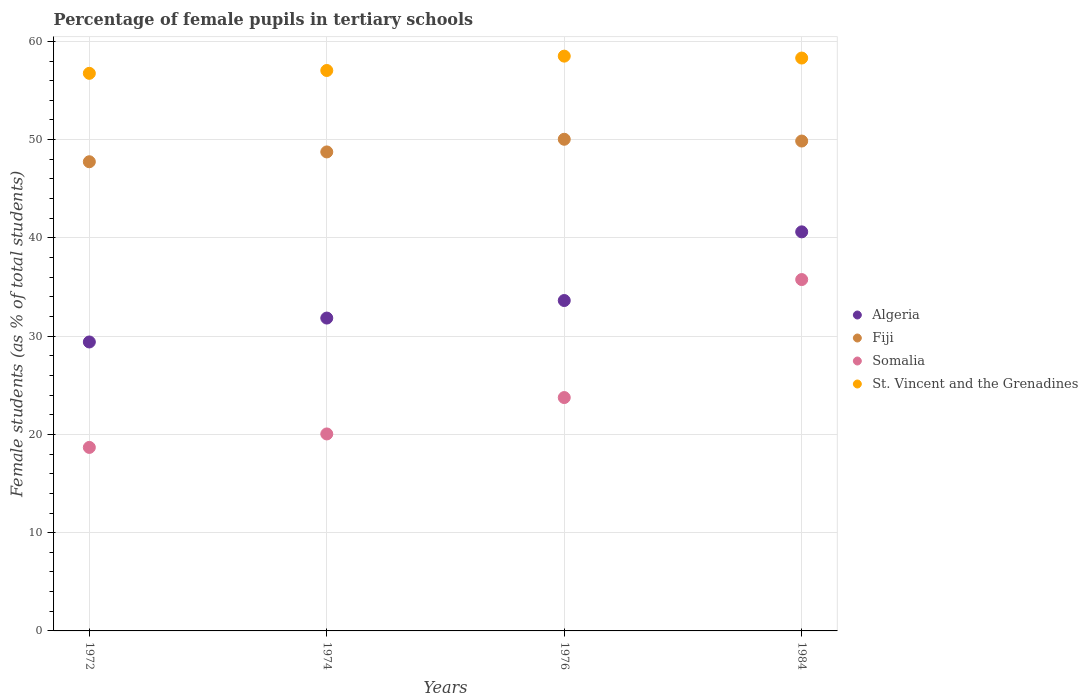How many different coloured dotlines are there?
Your answer should be very brief. 4. What is the percentage of female pupils in tertiary schools in Somalia in 1974?
Your answer should be compact. 20.05. Across all years, what is the maximum percentage of female pupils in tertiary schools in Algeria?
Give a very brief answer. 40.61. Across all years, what is the minimum percentage of female pupils in tertiary schools in Somalia?
Offer a terse response. 18.68. In which year was the percentage of female pupils in tertiary schools in Fiji maximum?
Provide a succinct answer. 1976. In which year was the percentage of female pupils in tertiary schools in St. Vincent and the Grenadines minimum?
Offer a terse response. 1972. What is the total percentage of female pupils in tertiary schools in Fiji in the graph?
Keep it short and to the point. 196.39. What is the difference between the percentage of female pupils in tertiary schools in St. Vincent and the Grenadines in 1974 and that in 1976?
Your answer should be very brief. -1.46. What is the difference between the percentage of female pupils in tertiary schools in Somalia in 1984 and the percentage of female pupils in tertiary schools in Fiji in 1976?
Make the answer very short. -14.28. What is the average percentage of female pupils in tertiary schools in Fiji per year?
Keep it short and to the point. 49.1. In the year 1974, what is the difference between the percentage of female pupils in tertiary schools in Fiji and percentage of female pupils in tertiary schools in St. Vincent and the Grenadines?
Ensure brevity in your answer.  -8.29. In how many years, is the percentage of female pupils in tertiary schools in St. Vincent and the Grenadines greater than 24 %?
Your response must be concise. 4. What is the ratio of the percentage of female pupils in tertiary schools in St. Vincent and the Grenadines in 1972 to that in 1976?
Provide a short and direct response. 0.97. What is the difference between the highest and the second highest percentage of female pupils in tertiary schools in Fiji?
Provide a succinct answer. 0.18. What is the difference between the highest and the lowest percentage of female pupils in tertiary schools in Fiji?
Your answer should be compact. 2.29. Is it the case that in every year, the sum of the percentage of female pupils in tertiary schools in Algeria and percentage of female pupils in tertiary schools in Somalia  is greater than the sum of percentage of female pupils in tertiary schools in St. Vincent and the Grenadines and percentage of female pupils in tertiary schools in Fiji?
Your answer should be compact. No. Is it the case that in every year, the sum of the percentage of female pupils in tertiary schools in Algeria and percentage of female pupils in tertiary schools in Fiji  is greater than the percentage of female pupils in tertiary schools in Somalia?
Your answer should be very brief. Yes. Is the percentage of female pupils in tertiary schools in Fiji strictly greater than the percentage of female pupils in tertiary schools in Somalia over the years?
Provide a succinct answer. Yes. Is the percentage of female pupils in tertiary schools in Algeria strictly less than the percentage of female pupils in tertiary schools in St. Vincent and the Grenadines over the years?
Your response must be concise. Yes. How many years are there in the graph?
Your response must be concise. 4. Are the values on the major ticks of Y-axis written in scientific E-notation?
Give a very brief answer. No. Does the graph contain grids?
Ensure brevity in your answer.  Yes. What is the title of the graph?
Provide a short and direct response. Percentage of female pupils in tertiary schools. Does "Slovenia" appear as one of the legend labels in the graph?
Ensure brevity in your answer.  No. What is the label or title of the Y-axis?
Offer a very short reply. Female students (as % of total students). What is the Female students (as % of total students) in Algeria in 1972?
Your response must be concise. 29.41. What is the Female students (as % of total students) in Fiji in 1972?
Offer a terse response. 47.75. What is the Female students (as % of total students) in Somalia in 1972?
Provide a succinct answer. 18.68. What is the Female students (as % of total students) of St. Vincent and the Grenadines in 1972?
Provide a short and direct response. 56.75. What is the Female students (as % of total students) of Algeria in 1974?
Keep it short and to the point. 31.84. What is the Female students (as % of total students) in Fiji in 1974?
Keep it short and to the point. 48.75. What is the Female students (as % of total students) of Somalia in 1974?
Provide a short and direct response. 20.05. What is the Female students (as % of total students) of St. Vincent and the Grenadines in 1974?
Give a very brief answer. 57.04. What is the Female students (as % of total students) of Algeria in 1976?
Your response must be concise. 33.63. What is the Female students (as % of total students) of Fiji in 1976?
Ensure brevity in your answer.  50.04. What is the Female students (as % of total students) in Somalia in 1976?
Offer a very short reply. 23.75. What is the Female students (as % of total students) of St. Vincent and the Grenadines in 1976?
Provide a succinct answer. 58.5. What is the Female students (as % of total students) in Algeria in 1984?
Offer a terse response. 40.61. What is the Female students (as % of total students) in Fiji in 1984?
Your answer should be compact. 49.86. What is the Female students (as % of total students) of Somalia in 1984?
Offer a very short reply. 35.76. What is the Female students (as % of total students) of St. Vincent and the Grenadines in 1984?
Your answer should be compact. 58.3. Across all years, what is the maximum Female students (as % of total students) of Algeria?
Provide a short and direct response. 40.61. Across all years, what is the maximum Female students (as % of total students) of Fiji?
Provide a succinct answer. 50.04. Across all years, what is the maximum Female students (as % of total students) in Somalia?
Your response must be concise. 35.76. Across all years, what is the maximum Female students (as % of total students) in St. Vincent and the Grenadines?
Your answer should be compact. 58.5. Across all years, what is the minimum Female students (as % of total students) of Algeria?
Keep it short and to the point. 29.41. Across all years, what is the minimum Female students (as % of total students) of Fiji?
Keep it short and to the point. 47.75. Across all years, what is the minimum Female students (as % of total students) in Somalia?
Provide a succinct answer. 18.68. Across all years, what is the minimum Female students (as % of total students) of St. Vincent and the Grenadines?
Provide a succinct answer. 56.75. What is the total Female students (as % of total students) of Algeria in the graph?
Provide a succinct answer. 135.49. What is the total Female students (as % of total students) in Fiji in the graph?
Give a very brief answer. 196.39. What is the total Female students (as % of total students) in Somalia in the graph?
Your answer should be very brief. 98.23. What is the total Female students (as % of total students) of St. Vincent and the Grenadines in the graph?
Give a very brief answer. 230.58. What is the difference between the Female students (as % of total students) of Algeria in 1972 and that in 1974?
Ensure brevity in your answer.  -2.43. What is the difference between the Female students (as % of total students) in Fiji in 1972 and that in 1974?
Your answer should be compact. -1. What is the difference between the Female students (as % of total students) of Somalia in 1972 and that in 1974?
Give a very brief answer. -1.37. What is the difference between the Female students (as % of total students) of St. Vincent and the Grenadines in 1972 and that in 1974?
Your answer should be compact. -0.29. What is the difference between the Female students (as % of total students) in Algeria in 1972 and that in 1976?
Provide a short and direct response. -4.22. What is the difference between the Female students (as % of total students) in Fiji in 1972 and that in 1976?
Ensure brevity in your answer.  -2.29. What is the difference between the Female students (as % of total students) of Somalia in 1972 and that in 1976?
Ensure brevity in your answer.  -5.07. What is the difference between the Female students (as % of total students) in St. Vincent and the Grenadines in 1972 and that in 1976?
Offer a terse response. -1.75. What is the difference between the Female students (as % of total students) of Algeria in 1972 and that in 1984?
Make the answer very short. -11.21. What is the difference between the Female students (as % of total students) of Fiji in 1972 and that in 1984?
Your response must be concise. -2.11. What is the difference between the Female students (as % of total students) of Somalia in 1972 and that in 1984?
Your answer should be compact. -17.08. What is the difference between the Female students (as % of total students) in St. Vincent and the Grenadines in 1972 and that in 1984?
Provide a short and direct response. -1.56. What is the difference between the Female students (as % of total students) in Algeria in 1974 and that in 1976?
Make the answer very short. -1.79. What is the difference between the Female students (as % of total students) of Fiji in 1974 and that in 1976?
Give a very brief answer. -1.29. What is the difference between the Female students (as % of total students) in Somalia in 1974 and that in 1976?
Offer a terse response. -3.7. What is the difference between the Female students (as % of total students) in St. Vincent and the Grenadines in 1974 and that in 1976?
Offer a terse response. -1.46. What is the difference between the Female students (as % of total students) in Algeria in 1974 and that in 1984?
Provide a short and direct response. -8.77. What is the difference between the Female students (as % of total students) of Fiji in 1974 and that in 1984?
Offer a terse response. -1.11. What is the difference between the Female students (as % of total students) in Somalia in 1974 and that in 1984?
Provide a succinct answer. -15.71. What is the difference between the Female students (as % of total students) of St. Vincent and the Grenadines in 1974 and that in 1984?
Offer a terse response. -1.27. What is the difference between the Female students (as % of total students) in Algeria in 1976 and that in 1984?
Your answer should be compact. -6.99. What is the difference between the Female students (as % of total students) in Fiji in 1976 and that in 1984?
Provide a short and direct response. 0.18. What is the difference between the Female students (as % of total students) of Somalia in 1976 and that in 1984?
Your response must be concise. -12.01. What is the difference between the Female students (as % of total students) in St. Vincent and the Grenadines in 1976 and that in 1984?
Make the answer very short. 0.19. What is the difference between the Female students (as % of total students) of Algeria in 1972 and the Female students (as % of total students) of Fiji in 1974?
Provide a short and direct response. -19.34. What is the difference between the Female students (as % of total students) in Algeria in 1972 and the Female students (as % of total students) in Somalia in 1974?
Offer a terse response. 9.36. What is the difference between the Female students (as % of total students) in Algeria in 1972 and the Female students (as % of total students) in St. Vincent and the Grenadines in 1974?
Offer a terse response. -27.63. What is the difference between the Female students (as % of total students) of Fiji in 1972 and the Female students (as % of total students) of Somalia in 1974?
Keep it short and to the point. 27.7. What is the difference between the Female students (as % of total students) of Fiji in 1972 and the Female students (as % of total students) of St. Vincent and the Grenadines in 1974?
Your answer should be compact. -9.29. What is the difference between the Female students (as % of total students) of Somalia in 1972 and the Female students (as % of total students) of St. Vincent and the Grenadines in 1974?
Keep it short and to the point. -38.36. What is the difference between the Female students (as % of total students) of Algeria in 1972 and the Female students (as % of total students) of Fiji in 1976?
Keep it short and to the point. -20.63. What is the difference between the Female students (as % of total students) in Algeria in 1972 and the Female students (as % of total students) in Somalia in 1976?
Offer a very short reply. 5.66. What is the difference between the Female students (as % of total students) in Algeria in 1972 and the Female students (as % of total students) in St. Vincent and the Grenadines in 1976?
Your answer should be very brief. -29.09. What is the difference between the Female students (as % of total students) in Fiji in 1972 and the Female students (as % of total students) in Somalia in 1976?
Offer a terse response. 24. What is the difference between the Female students (as % of total students) of Fiji in 1972 and the Female students (as % of total students) of St. Vincent and the Grenadines in 1976?
Provide a short and direct response. -10.75. What is the difference between the Female students (as % of total students) of Somalia in 1972 and the Female students (as % of total students) of St. Vincent and the Grenadines in 1976?
Offer a terse response. -39.82. What is the difference between the Female students (as % of total students) in Algeria in 1972 and the Female students (as % of total students) in Fiji in 1984?
Give a very brief answer. -20.45. What is the difference between the Female students (as % of total students) of Algeria in 1972 and the Female students (as % of total students) of Somalia in 1984?
Provide a short and direct response. -6.35. What is the difference between the Female students (as % of total students) in Algeria in 1972 and the Female students (as % of total students) in St. Vincent and the Grenadines in 1984?
Provide a short and direct response. -28.9. What is the difference between the Female students (as % of total students) of Fiji in 1972 and the Female students (as % of total students) of Somalia in 1984?
Make the answer very short. 11.99. What is the difference between the Female students (as % of total students) of Fiji in 1972 and the Female students (as % of total students) of St. Vincent and the Grenadines in 1984?
Keep it short and to the point. -10.55. What is the difference between the Female students (as % of total students) of Somalia in 1972 and the Female students (as % of total students) of St. Vincent and the Grenadines in 1984?
Offer a terse response. -39.63. What is the difference between the Female students (as % of total students) of Algeria in 1974 and the Female students (as % of total students) of Fiji in 1976?
Provide a succinct answer. -18.2. What is the difference between the Female students (as % of total students) in Algeria in 1974 and the Female students (as % of total students) in Somalia in 1976?
Provide a short and direct response. 8.09. What is the difference between the Female students (as % of total students) of Algeria in 1974 and the Female students (as % of total students) of St. Vincent and the Grenadines in 1976?
Give a very brief answer. -26.66. What is the difference between the Female students (as % of total students) in Fiji in 1974 and the Female students (as % of total students) in Somalia in 1976?
Your answer should be compact. 25. What is the difference between the Female students (as % of total students) in Fiji in 1974 and the Female students (as % of total students) in St. Vincent and the Grenadines in 1976?
Your answer should be compact. -9.75. What is the difference between the Female students (as % of total students) of Somalia in 1974 and the Female students (as % of total students) of St. Vincent and the Grenadines in 1976?
Provide a succinct answer. -38.45. What is the difference between the Female students (as % of total students) in Algeria in 1974 and the Female students (as % of total students) in Fiji in 1984?
Provide a short and direct response. -18.02. What is the difference between the Female students (as % of total students) of Algeria in 1974 and the Female students (as % of total students) of Somalia in 1984?
Give a very brief answer. -3.92. What is the difference between the Female students (as % of total students) of Algeria in 1974 and the Female students (as % of total students) of St. Vincent and the Grenadines in 1984?
Your answer should be compact. -26.46. What is the difference between the Female students (as % of total students) of Fiji in 1974 and the Female students (as % of total students) of Somalia in 1984?
Offer a terse response. 12.99. What is the difference between the Female students (as % of total students) in Fiji in 1974 and the Female students (as % of total students) in St. Vincent and the Grenadines in 1984?
Your response must be concise. -9.55. What is the difference between the Female students (as % of total students) of Somalia in 1974 and the Female students (as % of total students) of St. Vincent and the Grenadines in 1984?
Give a very brief answer. -38.26. What is the difference between the Female students (as % of total students) in Algeria in 1976 and the Female students (as % of total students) in Fiji in 1984?
Offer a very short reply. -16.23. What is the difference between the Female students (as % of total students) of Algeria in 1976 and the Female students (as % of total students) of Somalia in 1984?
Offer a very short reply. -2.13. What is the difference between the Female students (as % of total students) in Algeria in 1976 and the Female students (as % of total students) in St. Vincent and the Grenadines in 1984?
Keep it short and to the point. -24.68. What is the difference between the Female students (as % of total students) in Fiji in 1976 and the Female students (as % of total students) in Somalia in 1984?
Your answer should be compact. 14.28. What is the difference between the Female students (as % of total students) in Fiji in 1976 and the Female students (as % of total students) in St. Vincent and the Grenadines in 1984?
Keep it short and to the point. -8.27. What is the difference between the Female students (as % of total students) in Somalia in 1976 and the Female students (as % of total students) in St. Vincent and the Grenadines in 1984?
Ensure brevity in your answer.  -34.55. What is the average Female students (as % of total students) of Algeria per year?
Offer a terse response. 33.87. What is the average Female students (as % of total students) of Fiji per year?
Your answer should be very brief. 49.1. What is the average Female students (as % of total students) of Somalia per year?
Provide a short and direct response. 24.56. What is the average Female students (as % of total students) of St. Vincent and the Grenadines per year?
Your response must be concise. 57.65. In the year 1972, what is the difference between the Female students (as % of total students) in Algeria and Female students (as % of total students) in Fiji?
Provide a succinct answer. -18.34. In the year 1972, what is the difference between the Female students (as % of total students) in Algeria and Female students (as % of total students) in Somalia?
Offer a terse response. 10.73. In the year 1972, what is the difference between the Female students (as % of total students) in Algeria and Female students (as % of total students) in St. Vincent and the Grenadines?
Offer a terse response. -27.34. In the year 1972, what is the difference between the Female students (as % of total students) in Fiji and Female students (as % of total students) in Somalia?
Make the answer very short. 29.07. In the year 1972, what is the difference between the Female students (as % of total students) of Fiji and Female students (as % of total students) of St. Vincent and the Grenadines?
Your answer should be compact. -9. In the year 1972, what is the difference between the Female students (as % of total students) in Somalia and Female students (as % of total students) in St. Vincent and the Grenadines?
Give a very brief answer. -38.07. In the year 1974, what is the difference between the Female students (as % of total students) of Algeria and Female students (as % of total students) of Fiji?
Give a very brief answer. -16.91. In the year 1974, what is the difference between the Female students (as % of total students) in Algeria and Female students (as % of total students) in Somalia?
Keep it short and to the point. 11.79. In the year 1974, what is the difference between the Female students (as % of total students) of Algeria and Female students (as % of total students) of St. Vincent and the Grenadines?
Your answer should be compact. -25.2. In the year 1974, what is the difference between the Female students (as % of total students) of Fiji and Female students (as % of total students) of Somalia?
Your response must be concise. 28.7. In the year 1974, what is the difference between the Female students (as % of total students) of Fiji and Female students (as % of total students) of St. Vincent and the Grenadines?
Provide a short and direct response. -8.29. In the year 1974, what is the difference between the Female students (as % of total students) of Somalia and Female students (as % of total students) of St. Vincent and the Grenadines?
Provide a succinct answer. -36.99. In the year 1976, what is the difference between the Female students (as % of total students) in Algeria and Female students (as % of total students) in Fiji?
Give a very brief answer. -16.41. In the year 1976, what is the difference between the Female students (as % of total students) of Algeria and Female students (as % of total students) of Somalia?
Ensure brevity in your answer.  9.88. In the year 1976, what is the difference between the Female students (as % of total students) of Algeria and Female students (as % of total students) of St. Vincent and the Grenadines?
Provide a short and direct response. -24.87. In the year 1976, what is the difference between the Female students (as % of total students) of Fiji and Female students (as % of total students) of Somalia?
Ensure brevity in your answer.  26.29. In the year 1976, what is the difference between the Female students (as % of total students) of Fiji and Female students (as % of total students) of St. Vincent and the Grenadines?
Make the answer very short. -8.46. In the year 1976, what is the difference between the Female students (as % of total students) of Somalia and Female students (as % of total students) of St. Vincent and the Grenadines?
Your answer should be very brief. -34.75. In the year 1984, what is the difference between the Female students (as % of total students) in Algeria and Female students (as % of total students) in Fiji?
Your response must be concise. -9.24. In the year 1984, what is the difference between the Female students (as % of total students) of Algeria and Female students (as % of total students) of Somalia?
Provide a succinct answer. 4.86. In the year 1984, what is the difference between the Female students (as % of total students) in Algeria and Female students (as % of total students) in St. Vincent and the Grenadines?
Keep it short and to the point. -17.69. In the year 1984, what is the difference between the Female students (as % of total students) in Fiji and Female students (as % of total students) in Somalia?
Your response must be concise. 14.1. In the year 1984, what is the difference between the Female students (as % of total students) of Fiji and Female students (as % of total students) of St. Vincent and the Grenadines?
Provide a short and direct response. -8.45. In the year 1984, what is the difference between the Female students (as % of total students) of Somalia and Female students (as % of total students) of St. Vincent and the Grenadines?
Give a very brief answer. -22.54. What is the ratio of the Female students (as % of total students) of Algeria in 1972 to that in 1974?
Give a very brief answer. 0.92. What is the ratio of the Female students (as % of total students) of Fiji in 1972 to that in 1974?
Give a very brief answer. 0.98. What is the ratio of the Female students (as % of total students) in Somalia in 1972 to that in 1974?
Offer a terse response. 0.93. What is the ratio of the Female students (as % of total students) of Algeria in 1972 to that in 1976?
Make the answer very short. 0.87. What is the ratio of the Female students (as % of total students) in Fiji in 1972 to that in 1976?
Provide a short and direct response. 0.95. What is the ratio of the Female students (as % of total students) of Somalia in 1972 to that in 1976?
Offer a terse response. 0.79. What is the ratio of the Female students (as % of total students) of St. Vincent and the Grenadines in 1972 to that in 1976?
Make the answer very short. 0.97. What is the ratio of the Female students (as % of total students) of Algeria in 1972 to that in 1984?
Ensure brevity in your answer.  0.72. What is the ratio of the Female students (as % of total students) of Fiji in 1972 to that in 1984?
Provide a succinct answer. 0.96. What is the ratio of the Female students (as % of total students) in Somalia in 1972 to that in 1984?
Make the answer very short. 0.52. What is the ratio of the Female students (as % of total students) in St. Vincent and the Grenadines in 1972 to that in 1984?
Give a very brief answer. 0.97. What is the ratio of the Female students (as % of total students) of Algeria in 1974 to that in 1976?
Your response must be concise. 0.95. What is the ratio of the Female students (as % of total students) of Fiji in 1974 to that in 1976?
Ensure brevity in your answer.  0.97. What is the ratio of the Female students (as % of total students) of Somalia in 1974 to that in 1976?
Ensure brevity in your answer.  0.84. What is the ratio of the Female students (as % of total students) in Algeria in 1974 to that in 1984?
Ensure brevity in your answer.  0.78. What is the ratio of the Female students (as % of total students) of Fiji in 1974 to that in 1984?
Your response must be concise. 0.98. What is the ratio of the Female students (as % of total students) of Somalia in 1974 to that in 1984?
Make the answer very short. 0.56. What is the ratio of the Female students (as % of total students) of St. Vincent and the Grenadines in 1974 to that in 1984?
Make the answer very short. 0.98. What is the ratio of the Female students (as % of total students) of Algeria in 1976 to that in 1984?
Provide a succinct answer. 0.83. What is the ratio of the Female students (as % of total students) of Somalia in 1976 to that in 1984?
Your answer should be very brief. 0.66. What is the difference between the highest and the second highest Female students (as % of total students) in Algeria?
Provide a short and direct response. 6.99. What is the difference between the highest and the second highest Female students (as % of total students) of Fiji?
Offer a very short reply. 0.18. What is the difference between the highest and the second highest Female students (as % of total students) of Somalia?
Make the answer very short. 12.01. What is the difference between the highest and the second highest Female students (as % of total students) of St. Vincent and the Grenadines?
Ensure brevity in your answer.  0.19. What is the difference between the highest and the lowest Female students (as % of total students) in Algeria?
Your answer should be very brief. 11.21. What is the difference between the highest and the lowest Female students (as % of total students) in Fiji?
Make the answer very short. 2.29. What is the difference between the highest and the lowest Female students (as % of total students) of Somalia?
Your response must be concise. 17.08. What is the difference between the highest and the lowest Female students (as % of total students) in St. Vincent and the Grenadines?
Ensure brevity in your answer.  1.75. 